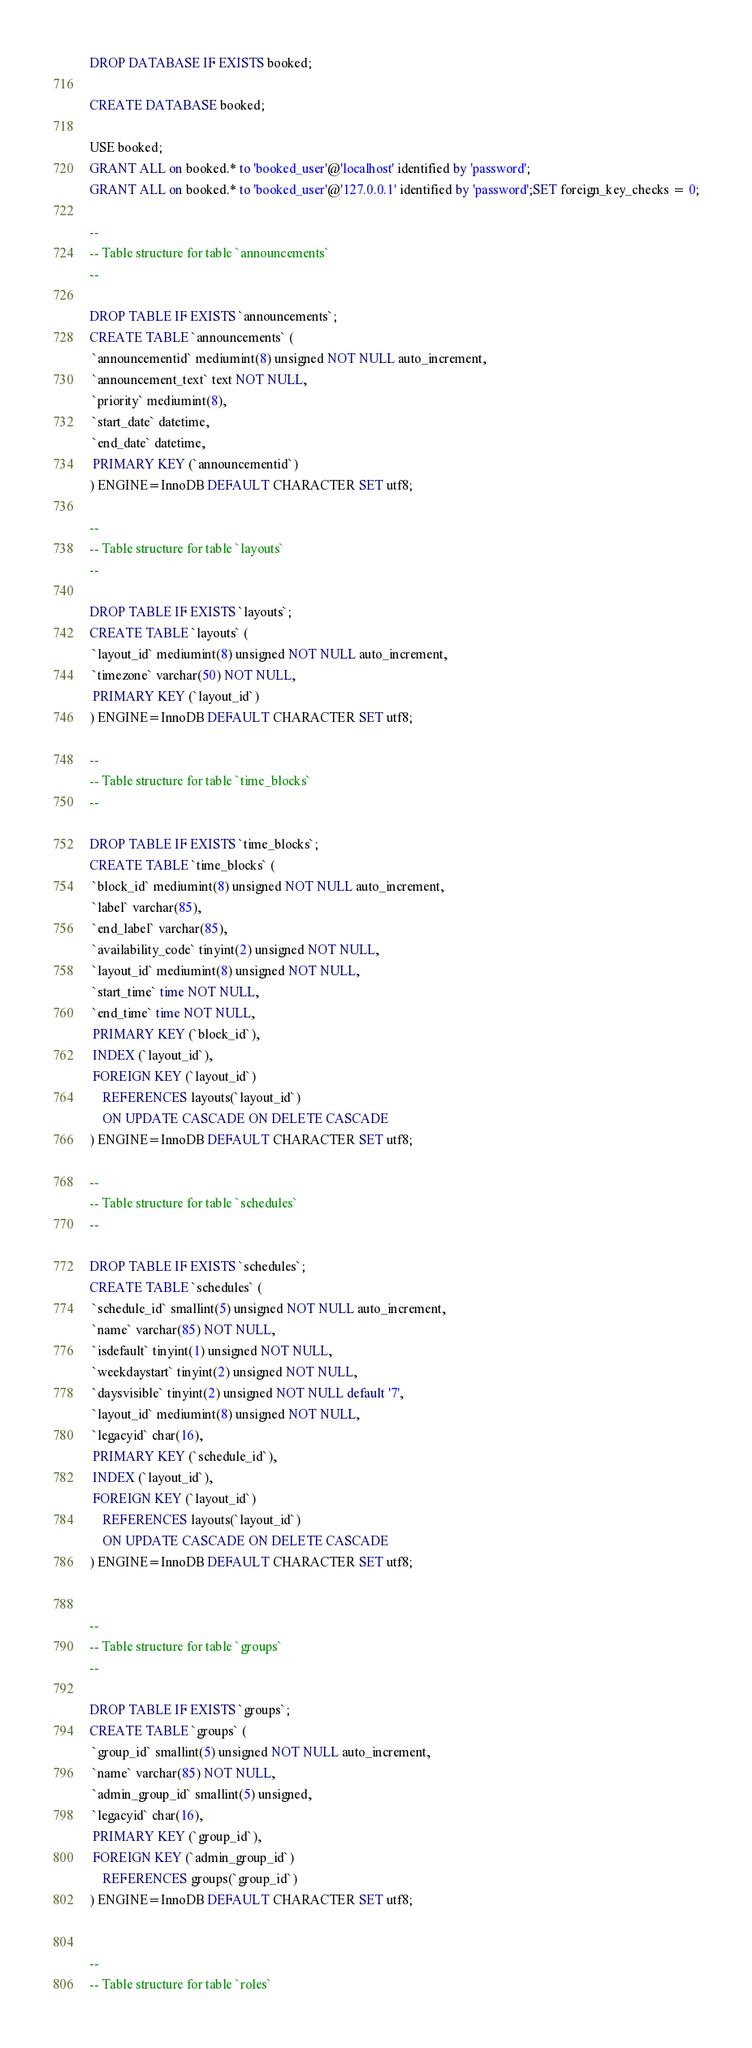<code> <loc_0><loc_0><loc_500><loc_500><_SQL_>DROP DATABASE IF EXISTS booked;

CREATE DATABASE booked;

USE booked;
GRANT ALL on booked.* to 'booked_user'@'localhost' identified by 'password';
GRANT ALL on booked.* to 'booked_user'@'127.0.0.1' identified by 'password';SET foreign_key_checks = 0;

--
-- Table structure for table `announcements`
--

DROP TABLE IF EXISTS `announcements`;
CREATE TABLE `announcements` (
 `announcementid` mediumint(8) unsigned NOT NULL auto_increment,
 `announcement_text` text NOT NULL,
 `priority` mediumint(8),
 `start_date` datetime,
 `end_date` datetime,
 PRIMARY KEY (`announcementid`)
) ENGINE=InnoDB DEFAULT CHARACTER SET utf8;

--
-- Table structure for table `layouts`
--

DROP TABLE IF EXISTS `layouts`;
CREATE TABLE `layouts` (
 `layout_id` mediumint(8) unsigned NOT NULL auto_increment,
 `timezone` varchar(50) NOT NULL,
 PRIMARY KEY (`layout_id`)
) ENGINE=InnoDB DEFAULT CHARACTER SET utf8;

--
-- Table structure for table `time_blocks`
--

DROP TABLE IF EXISTS `time_blocks`;
CREATE TABLE `time_blocks` (
 `block_id` mediumint(8) unsigned NOT NULL auto_increment,
 `label` varchar(85),
 `end_label` varchar(85),
 `availability_code` tinyint(2) unsigned NOT NULL,
 `layout_id` mediumint(8) unsigned NOT NULL,
 `start_time` time NOT NULL,
 `end_time` time NOT NULL,
 PRIMARY KEY (`block_id`),
 INDEX (`layout_id`),
 FOREIGN KEY (`layout_id`) 
	REFERENCES layouts(`layout_id`)
	ON UPDATE CASCADE ON DELETE CASCADE
) ENGINE=InnoDB DEFAULT CHARACTER SET utf8;

--
-- Table structure for table `schedules`
--

DROP TABLE IF EXISTS `schedules`;
CREATE TABLE `schedules` (
 `schedule_id` smallint(5) unsigned NOT NULL auto_increment,
 `name` varchar(85) NOT NULL,
 `isdefault` tinyint(1) unsigned NOT NULL,
 `weekdaystart` tinyint(2) unsigned NOT NULL,
 `daysvisible` tinyint(2) unsigned NOT NULL default '7',
 `layout_id` mediumint(8) unsigned NOT NULL,
 `legacyid` char(16),
 PRIMARY KEY (`schedule_id`),
 INDEX (`layout_id`),
 FOREIGN KEY (`layout_id`)
	REFERENCES layouts(`layout_id`)
	ON UPDATE CASCADE ON DELETE CASCADE
) ENGINE=InnoDB DEFAULT CHARACTER SET utf8;


--
-- Table structure for table `groups`
--

DROP TABLE IF EXISTS `groups`;
CREATE TABLE `groups` (
 `group_id` smallint(5) unsigned NOT NULL auto_increment,
 `name` varchar(85) NOT NULL,
 `admin_group_id` smallint(5) unsigned,
 `legacyid` char(16),
 PRIMARY KEY (`group_id`),
 FOREIGN KEY (`admin_group_id`)
	REFERENCES groups(`group_id`)
) ENGINE=InnoDB DEFAULT CHARACTER SET utf8;


--
-- Table structure for table `roles`</code> 